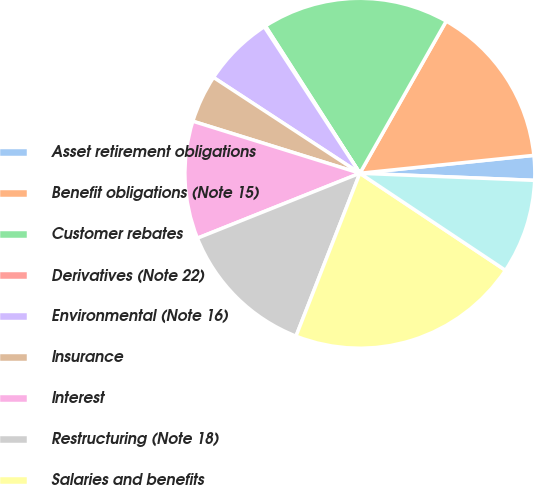<chart> <loc_0><loc_0><loc_500><loc_500><pie_chart><fcel>Asset retirement obligations<fcel>Benefit obligations (Note 15)<fcel>Customer rebates<fcel>Derivatives (Note 22)<fcel>Environmental (Note 16)<fcel>Insurance<fcel>Interest<fcel>Restructuring (Note 18)<fcel>Salaries and benefits<fcel>Sales and use tax/foreign<nl><fcel>2.28%<fcel>15.15%<fcel>17.29%<fcel>0.13%<fcel>6.57%<fcel>4.42%<fcel>10.86%<fcel>13.0%<fcel>21.59%<fcel>8.71%<nl></chart> 